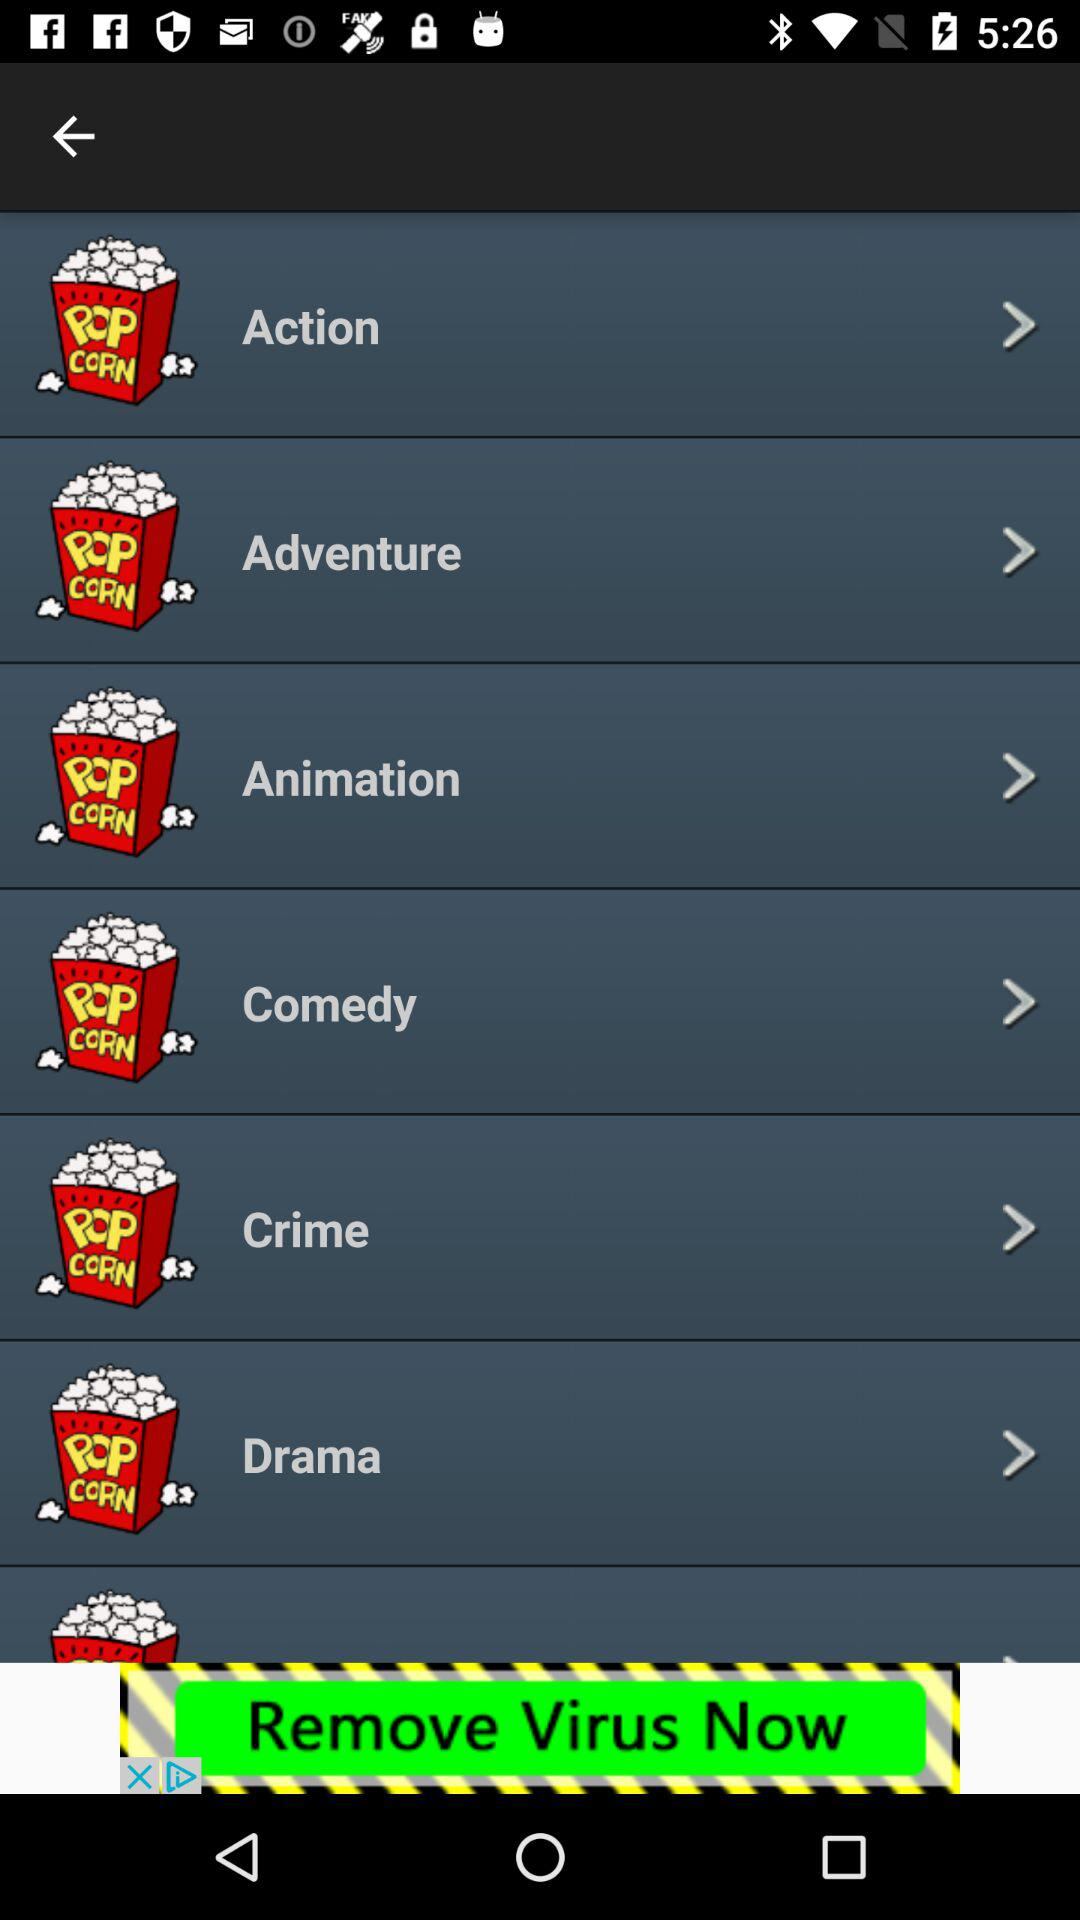How many genres are there in total?
Answer the question using a single word or phrase. 6 